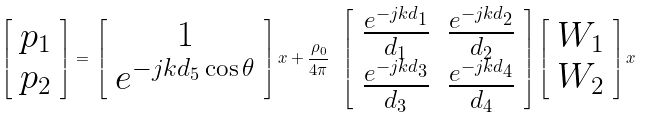<formula> <loc_0><loc_0><loc_500><loc_500>\left [ \begin{array} { c } p _ { 1 } \\ p _ { 2 } \end{array} \right ] = \, \left [ \begin{array} { c } 1 \\ e ^ { - j k d _ { 5 } \cos \theta } \end{array} \right ] x + \frac { \rho _ { 0 } } { 4 \pi } \, \ \left [ \begin{array} { c c } \frac { e ^ { - j k d _ { 1 } } } { d _ { 1 } } & \frac { e ^ { - j k d _ { 2 } } } { d _ { 2 } } \\ \frac { e ^ { - j k d _ { 3 } } } { d _ { 3 } } & \frac { e ^ { - j k d _ { 4 } } } { d _ { 4 } } \end{array} \right ] \left [ \begin{array} { c } W _ { 1 } \\ W _ { 2 } \end{array} \right ] x</formula> 